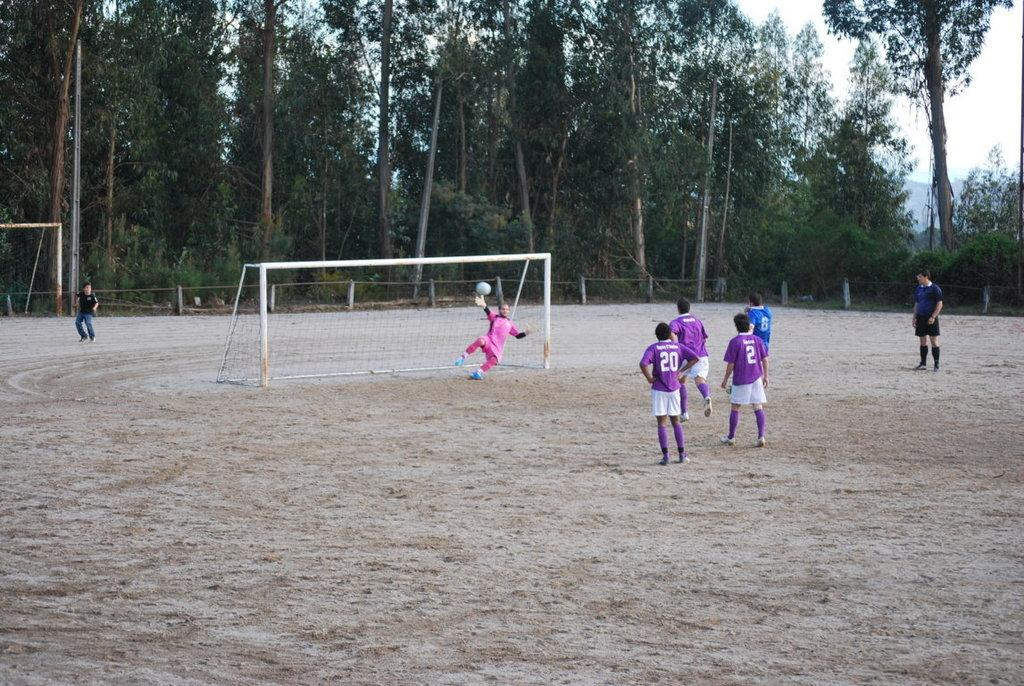<image>
Give a short and clear explanation of the subsequent image. two teams playing soccer, including purple team numbers 20 and 2 